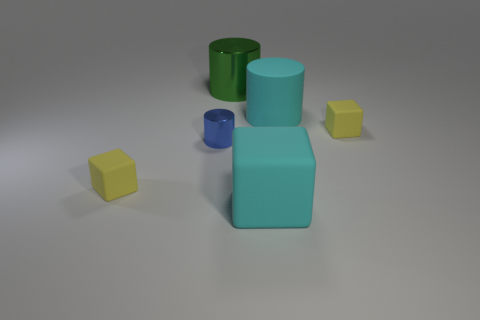Add 4 cyan rubber things. How many objects exist? 10 Subtract all small yellow rubber cubes. How many cubes are left? 1 Subtract all yellow balls. How many yellow cubes are left? 2 Subtract all yellow cubes. How many cubes are left? 1 Subtract 2 cylinders. How many cylinders are left? 1 Subtract all matte cubes. Subtract all tiny blue metallic cylinders. How many objects are left? 2 Add 4 large cyan rubber cubes. How many large cyan rubber cubes are left? 5 Add 1 large cylinders. How many large cylinders exist? 3 Subtract 0 purple cubes. How many objects are left? 6 Subtract all gray cylinders. Subtract all red balls. How many cylinders are left? 3 